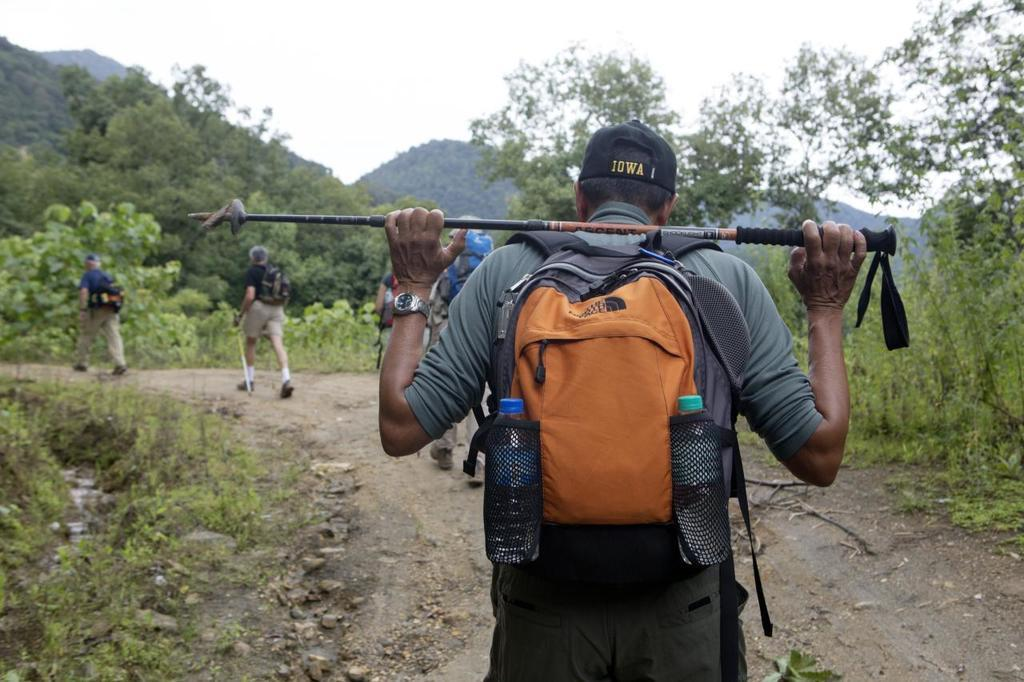Provide a one-sentence caption for the provided image. A man with an Iowa hat his hiking and holding a ski pole. 